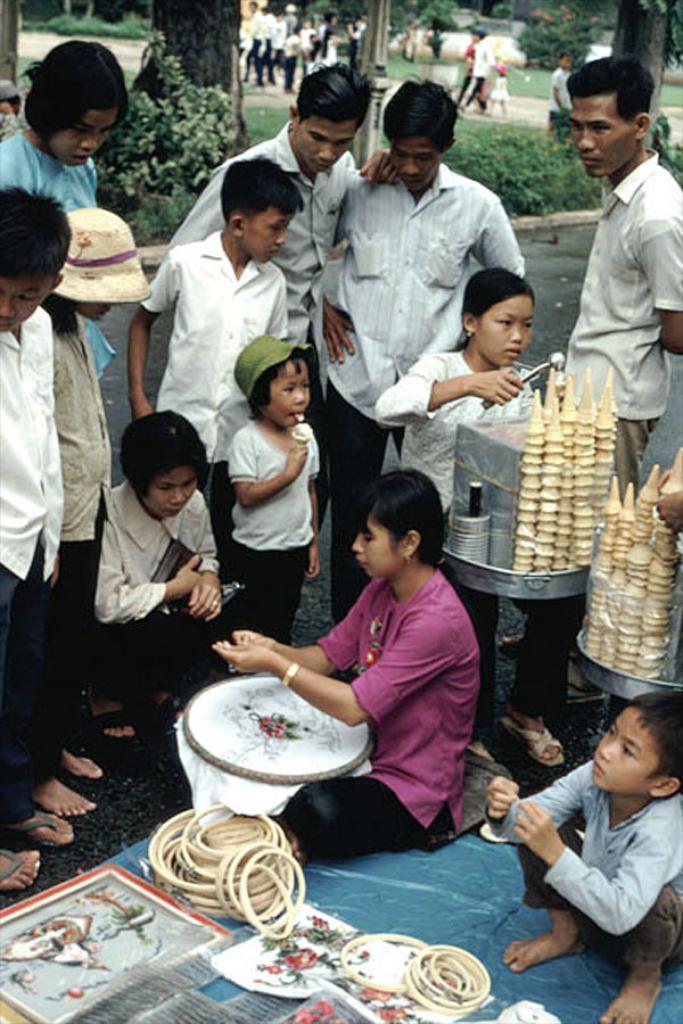How would you summarize this image in a sentence or two? In this image in the center there are some people who are standing, and also there are some children. On the right side there are some cones and one girl is holding something, in front of her there are some boxes and some utensils. At the bottom there is one woman who is sitting and she is holding one cloth and a board. Beside her there are some objects, plates and one boy is sitting. In the background there are some trees and some people are walking, in the center there is one pole. 